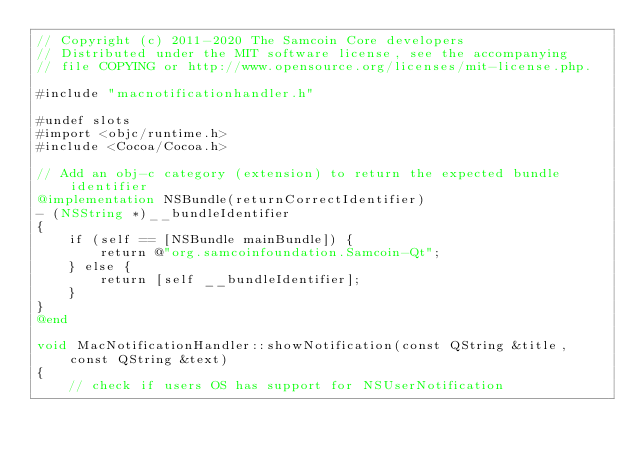Convert code to text. <code><loc_0><loc_0><loc_500><loc_500><_ObjectiveC_>// Copyright (c) 2011-2020 The Samcoin Core developers
// Distributed under the MIT software license, see the accompanying
// file COPYING or http://www.opensource.org/licenses/mit-license.php.

#include "macnotificationhandler.h"

#undef slots
#import <objc/runtime.h>
#include <Cocoa/Cocoa.h>

// Add an obj-c category (extension) to return the expected bundle identifier
@implementation NSBundle(returnCorrectIdentifier)
- (NSString *)__bundleIdentifier
{
    if (self == [NSBundle mainBundle]) {
        return @"org.samcoinfoundation.Samcoin-Qt";
    } else {
        return [self __bundleIdentifier];
    }
}
@end

void MacNotificationHandler::showNotification(const QString &title, const QString &text)
{
    // check if users OS has support for NSUserNotification</code> 